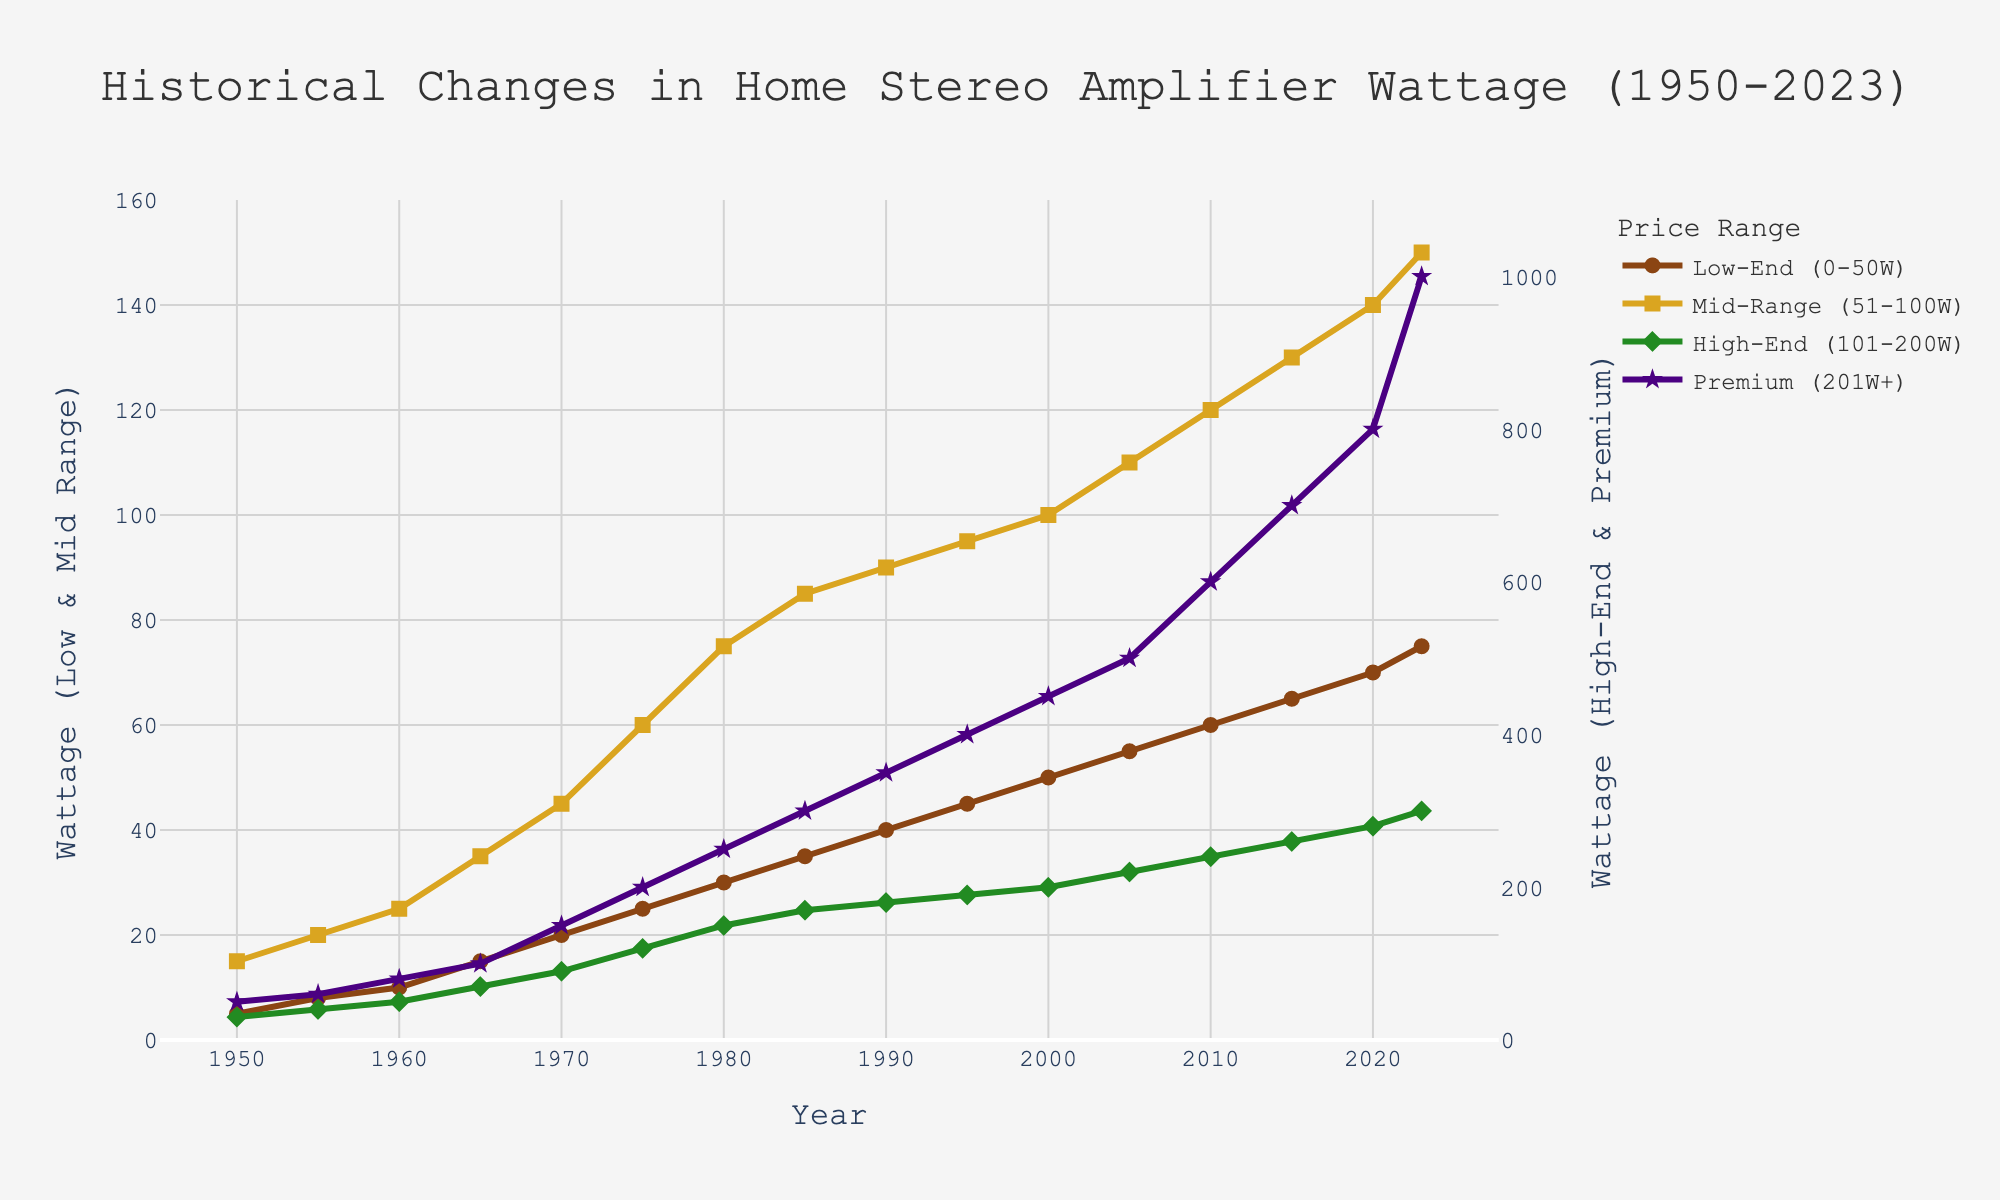What is the wattage output of the Low-End amplifiers in 1950 and 2023? In 1950, the wattage output is at the starting data point for Low-End, and in 2023, it is at the final data point for Low-End in the line plot.
Answer: 5, 75 Which price range saw the greatest increase in wattage output from 1950 to 2023? Calculate the difference in wattage output from 1950 to 2023 for each price range and compare them. Low-End: 75-5=70, Mid-Range: 150-15=135, High-End: 300-30=270, Premium: 1000-50=950. The Premium range saw the greatest increase.
Answer: Premium What is the difference in wattage output between Mid-Range and High-End amplifiers in 1980? Locate the 1980 data points for both Mid-Range and High-End in the line plot, and subtract the Mid-Range wattage from the High-End wattage (150-75).
Answer: 75 In which decade did the wattage output for Low-End amplifiers exceed 50W for the first time? Identify the year when Low-End first exceeds 50W. It happens in the 2000s when the wattage reaches 55W.
Answer: 2000s Between which pairs of price ranges does the wattage output cross during the years 1970 to 1975? Analyze the lines between 1970 and 1975. Check for points where one price range's line crosses another. No lines indicate a crossover in this period; they all rise without intersecting.
Answer: None What is the average wattage output for the Premium range from 1950 to 2023? Sum the wattage output for the Premium range over all years given and divide by the number of years (50+60+80+100+150+200+250+300+350+400+450+500+600+700+800+1000)/16.
Answer: 355.625 Compare the wattage output trend for Mid-Range and High-End amplifiers from 1960 to 1980. Which one had a steeper rise? Calculate the change in wattage for both ranges within the period and compare. For Mid-Range: 75-25=50. For High-End: 150-50=100. High-End had a steeper rise.
Answer: High-End At what year did the wattage of Low-End amplifiers equal the wattage of Mid-Range amplifiers from 1960? Identify when the Low-End wattage reads 25W, which was the Mid-Range wattage in 1960. This occurs in 1960 for Mid-Range and matches with Low-End in 1980.
Answer: 1980 Between which years did the wattage output for Premium amplifiers see its most significant single-year increase? Look for the largest single-year jump in the Premium line. The sharpest increase appears between 2020 (800W) and 2023 (1000W), giving a change of 200W.
Answer: 2020-2023 